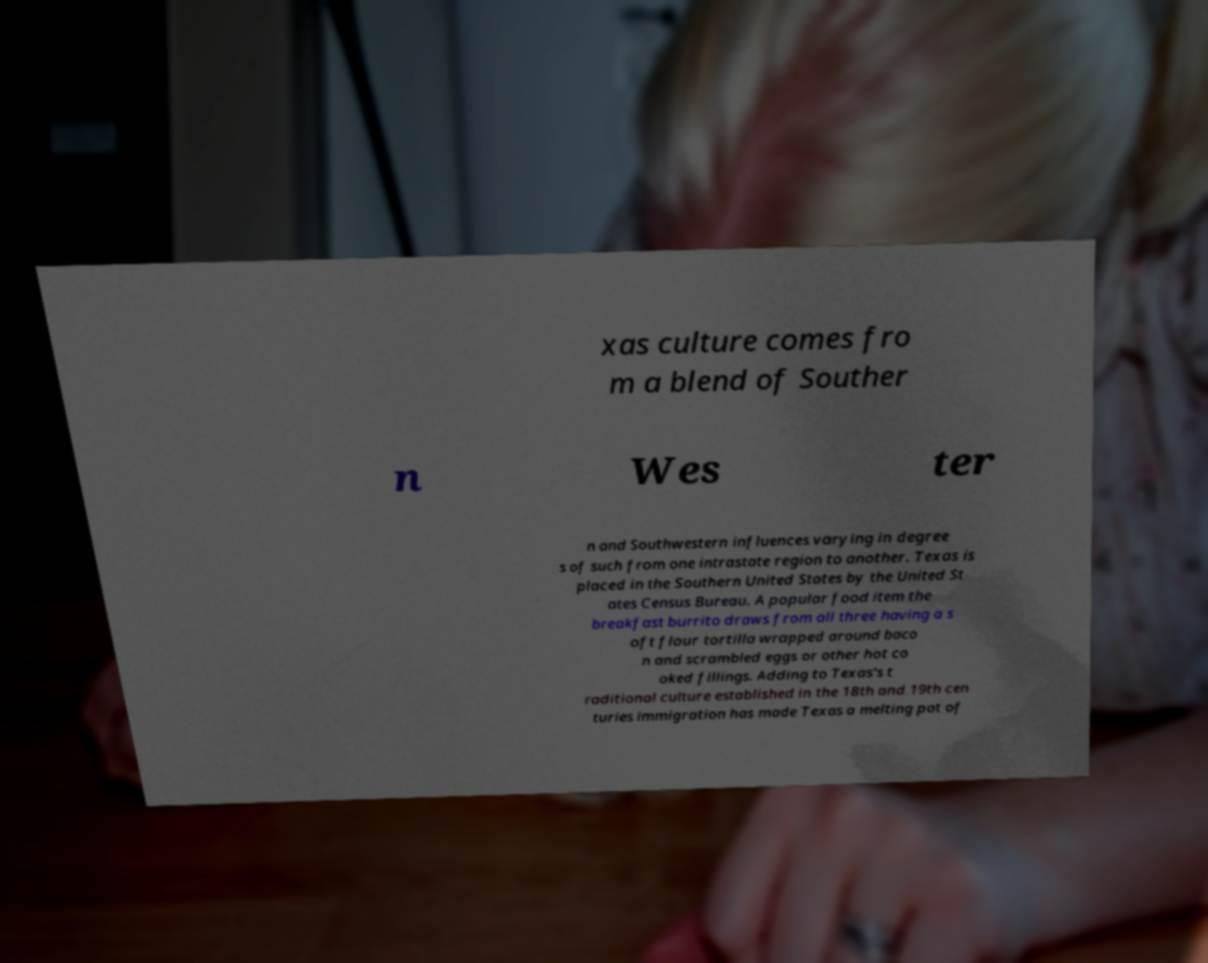Please identify and transcribe the text found in this image. xas culture comes fro m a blend of Souther n Wes ter n and Southwestern influences varying in degree s of such from one intrastate region to another. Texas is placed in the Southern United States by the United St ates Census Bureau. A popular food item the breakfast burrito draws from all three having a s oft flour tortilla wrapped around baco n and scrambled eggs or other hot co oked fillings. Adding to Texas's t raditional culture established in the 18th and 19th cen turies immigration has made Texas a melting pot of 